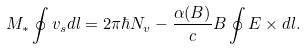<formula> <loc_0><loc_0><loc_500><loc_500>M _ { * } \oint { v } _ { s } d { l } = 2 \pi \hbar { N } _ { v } - \frac { \alpha ( B ) } { c } B \oint { E } \times d { l } .</formula> 